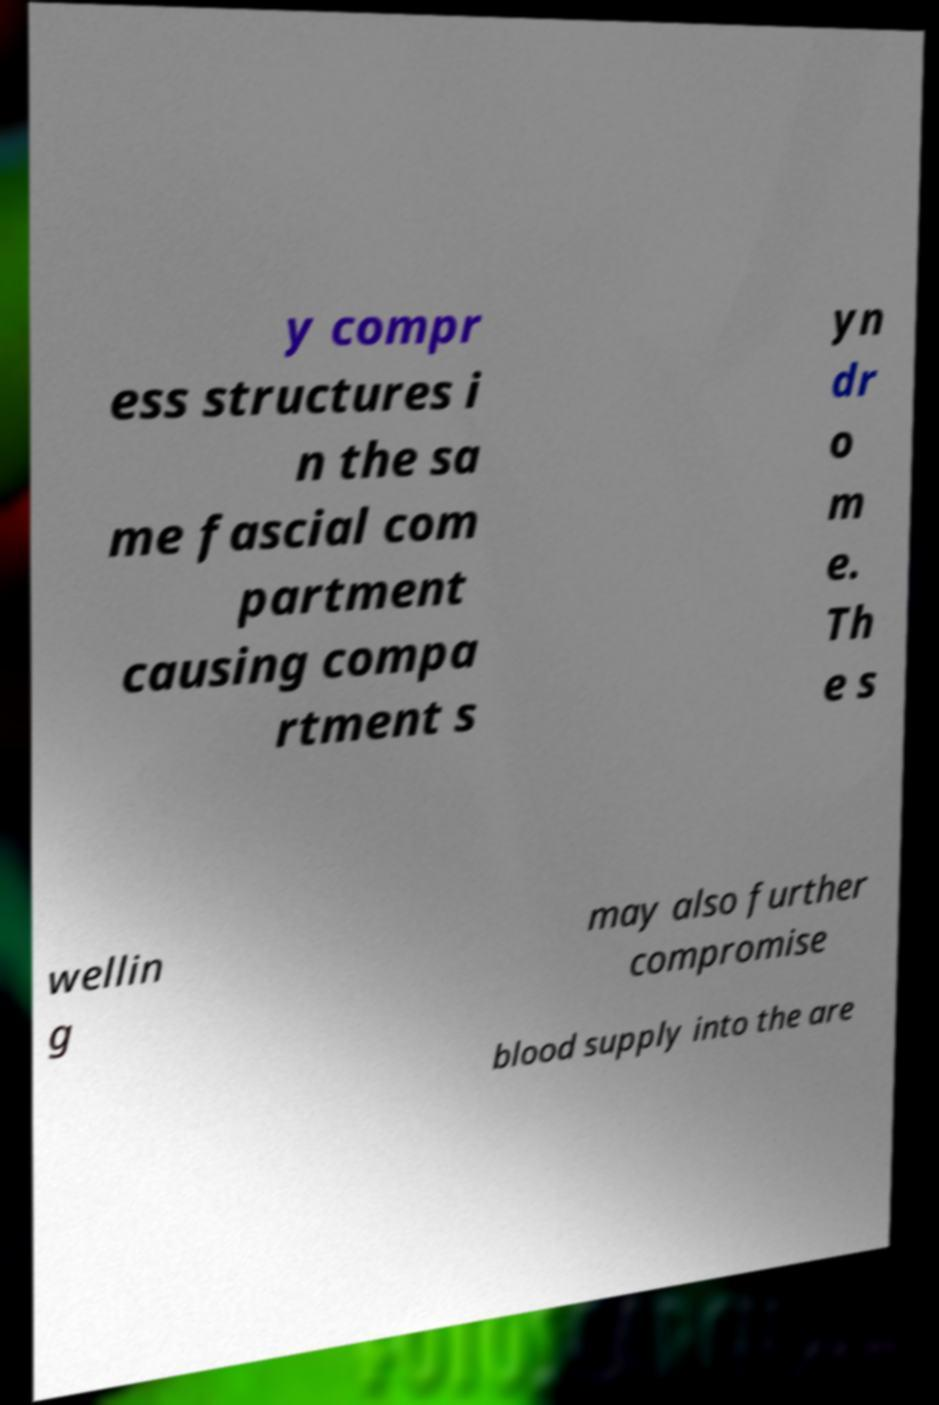For documentation purposes, I need the text within this image transcribed. Could you provide that? y compr ess structures i n the sa me fascial com partment causing compa rtment s yn dr o m e. Th e s wellin g may also further compromise blood supply into the are 